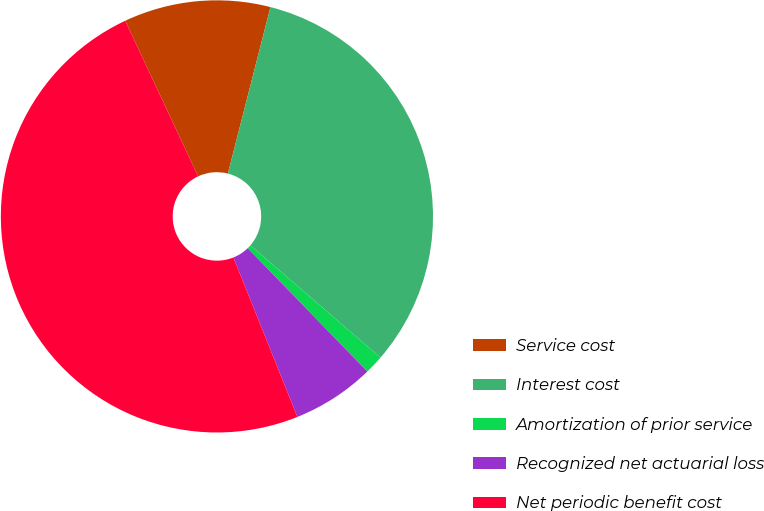Convert chart to OTSL. <chart><loc_0><loc_0><loc_500><loc_500><pie_chart><fcel>Service cost<fcel>Interest cost<fcel>Amortization of prior service<fcel>Recognized net actuarial loss<fcel>Net periodic benefit cost<nl><fcel>10.96%<fcel>32.35%<fcel>1.41%<fcel>6.18%<fcel>49.1%<nl></chart> 